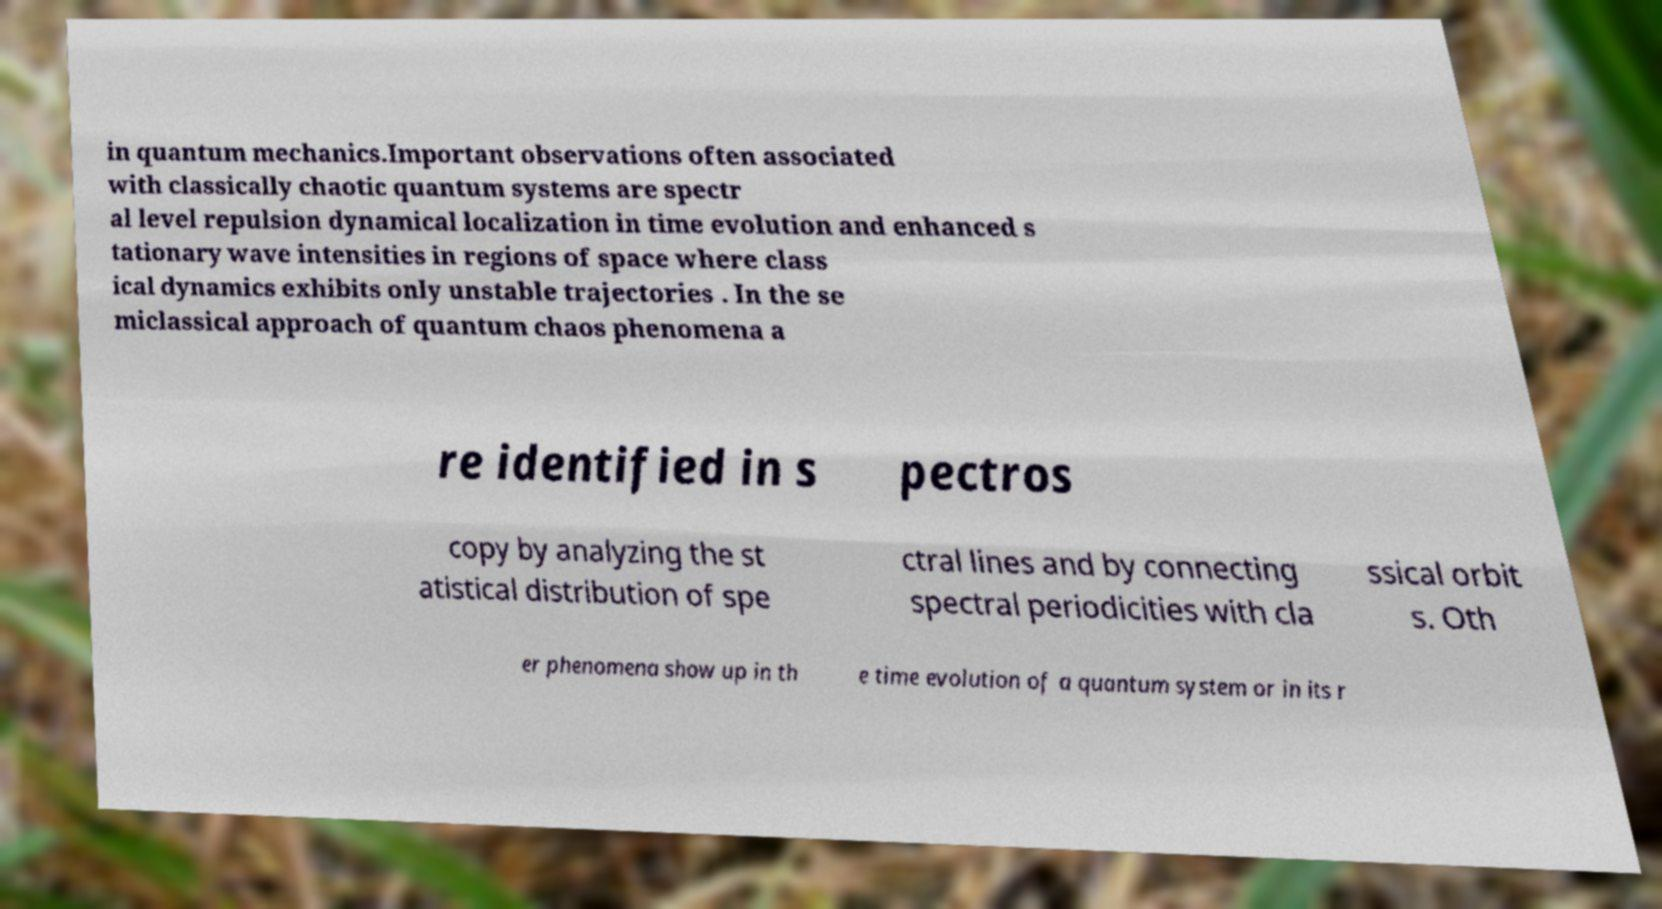Can you accurately transcribe the text from the provided image for me? in quantum mechanics.Important observations often associated with classically chaotic quantum systems are spectr al level repulsion dynamical localization in time evolution and enhanced s tationary wave intensities in regions of space where class ical dynamics exhibits only unstable trajectories . In the se miclassical approach of quantum chaos phenomena a re identified in s pectros copy by analyzing the st atistical distribution of spe ctral lines and by connecting spectral periodicities with cla ssical orbit s. Oth er phenomena show up in th e time evolution of a quantum system or in its r 